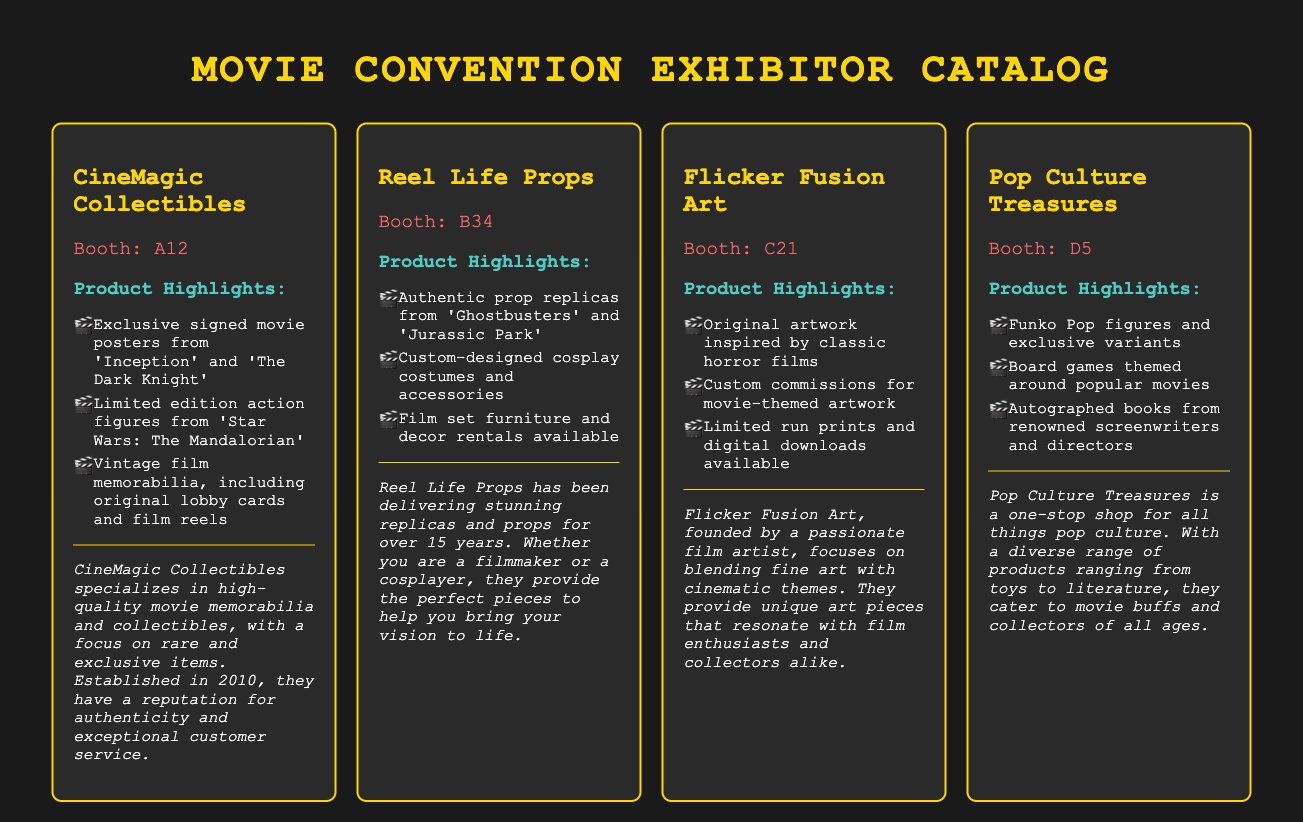What is the booth location of CineMagic Collectibles? The booth location is mentioned directly under the vendor name in the exhibitor card for CineMagic Collectibles.
Answer: Booth: A12 Which vendor specializes in custom-designed cosplay costumes? The vendor that specializes in custom-designed cosplay costumes is mentioned in their profile.
Answer: Reel Life Props How many exhibitors are listed in the catalog? The total number of exhibitors is determined by counting each exhibitor card presented in the document.
Answer: Four What product highlights does Flicker Fusion Art offer? The product highlights for Flicker Fusion Art are listed in bullet points, including original artwork inspired by classic horror films.
Answer: Original artwork inspired by classic horror films What is the main focus of Pop Culture Treasures? The main focus of Pop Culture Treasures can be inferred from their vendor profile that mentions a diverse range of products catered to movie buffs and collectors.
Answer: All things pop culture 